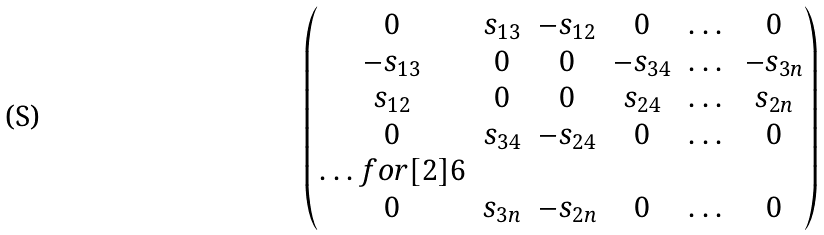<formula> <loc_0><loc_0><loc_500><loc_500>\begin{pmatrix} 0 & s _ { 1 3 } & - s _ { 1 2 } & 0 & \dots & 0 \\ - s _ { 1 3 } & 0 & 0 & - s _ { 3 4 } & \dots & - s _ { 3 n } \\ s _ { 1 2 } & 0 & 0 & s _ { 2 4 } & \dots & s _ { 2 n } \\ 0 & s _ { 3 4 } & - s _ { 2 4 } & 0 & \dots & 0 \\ \hdots f o r [ 2 ] { 6 } \\ 0 & s _ { 3 n } & - s _ { 2 n } & 0 & \dots & 0 \\ \end{pmatrix}</formula> 